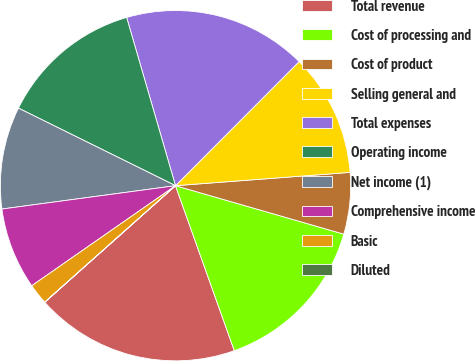Convert chart. <chart><loc_0><loc_0><loc_500><loc_500><pie_chart><fcel>Total revenue<fcel>Cost of processing and<fcel>Cost of product<fcel>Selling general and<fcel>Total expenses<fcel>Operating income<fcel>Net income (1)<fcel>Comprehensive income<fcel>Basic<fcel>Diluted<nl><fcel>18.86%<fcel>15.09%<fcel>5.67%<fcel>11.32%<fcel>16.97%<fcel>13.2%<fcel>9.43%<fcel>7.55%<fcel>1.9%<fcel>0.01%<nl></chart> 